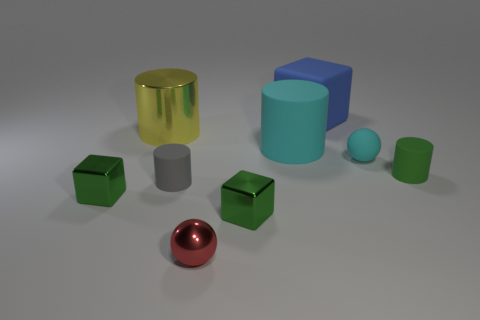Subtract 1 cylinders. How many cylinders are left? 3 Add 1 tiny blue matte cylinders. How many objects exist? 10 Subtract all cylinders. How many objects are left? 5 Subtract all tiny gray matte objects. Subtract all small red metal balls. How many objects are left? 7 Add 5 green metal cubes. How many green metal cubes are left? 7 Add 2 tiny red balls. How many tiny red balls exist? 3 Subtract 1 red spheres. How many objects are left? 8 